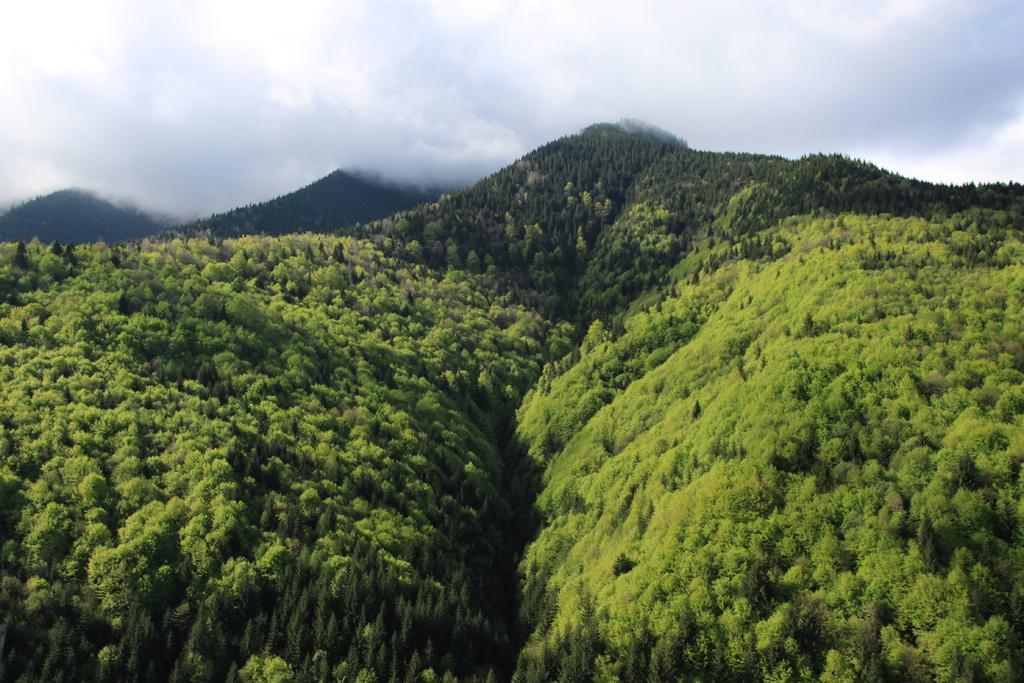Could you give a brief overview of what you see in this image? This picture might be taken outside of the city. In this image, we can see some trees. In the background, there are some mountains. On the top, we can see a sky which is cloudy. 